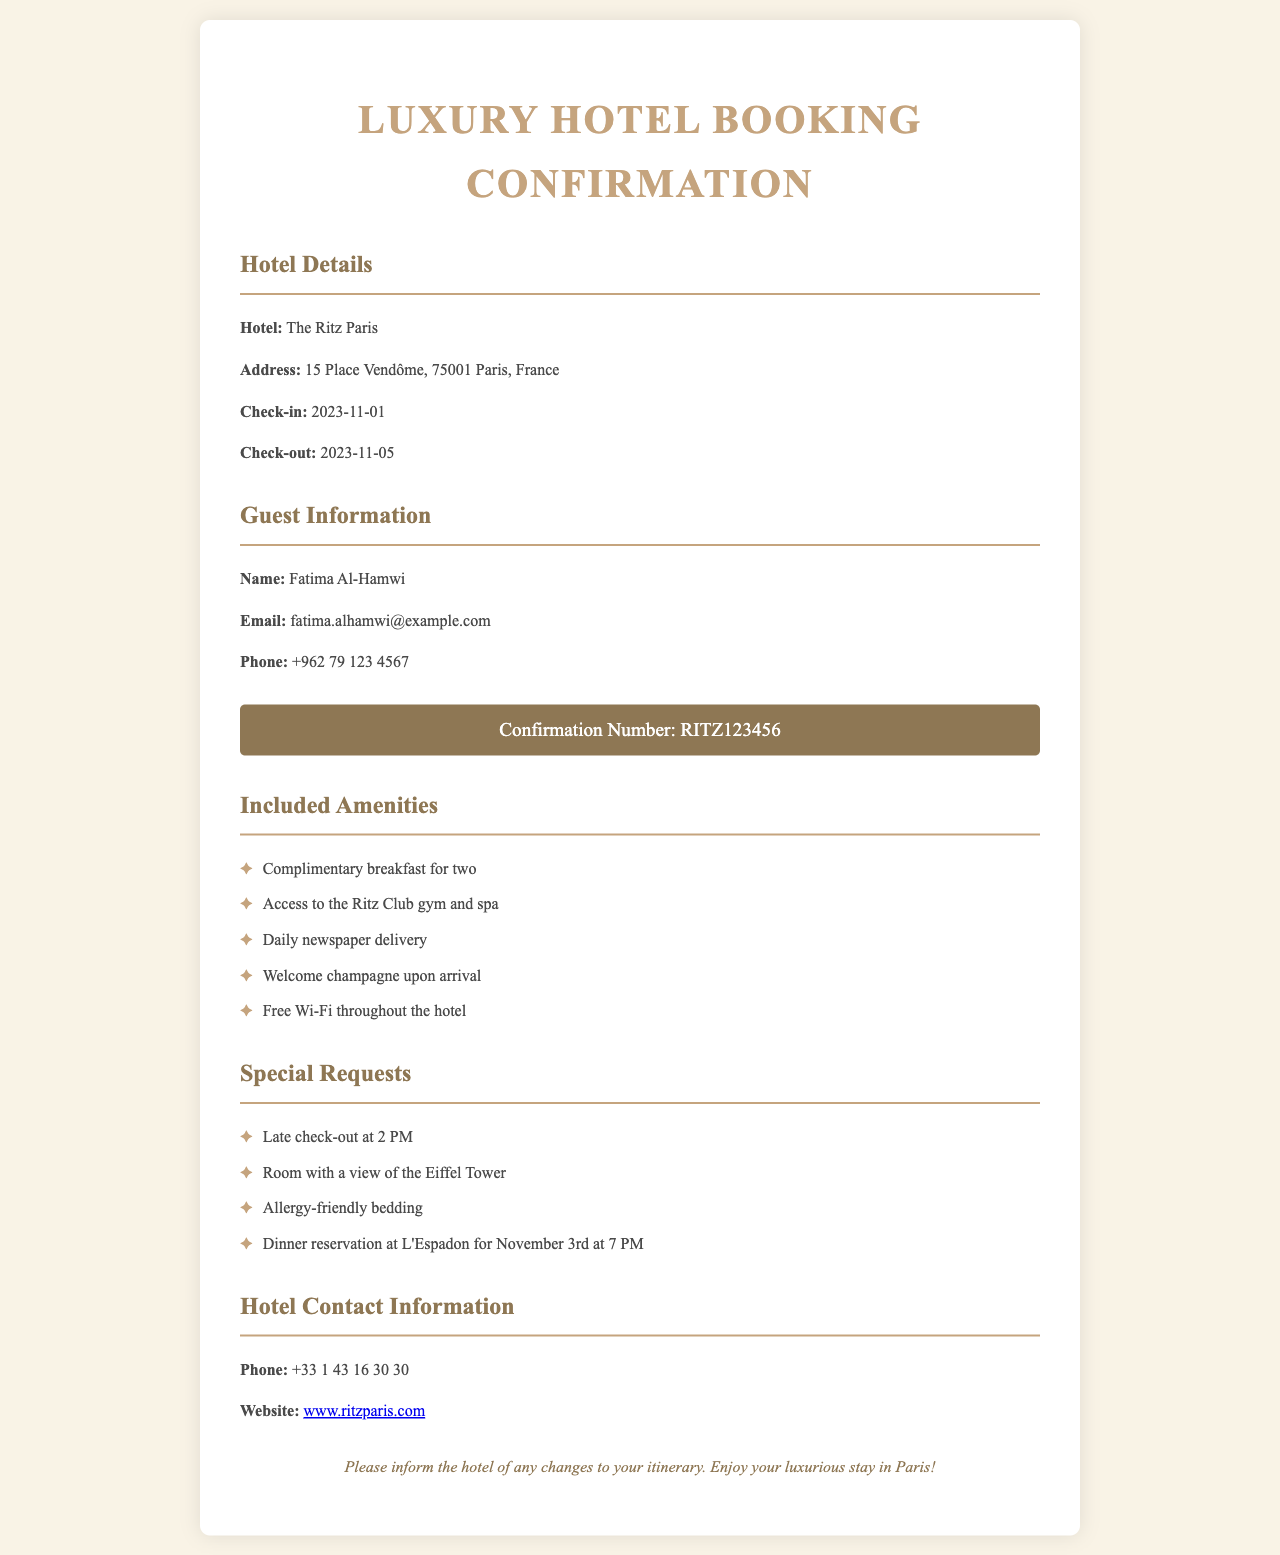What is the hotel name? The hotel name is mentioned in the hotel details section of the document.
Answer: The Ritz Paris What are the check-in and check-out dates? The check-in and check-out dates are specified in the hotel details section.
Answer: 2023-11-01 and 2023-11-05 What amenities are included? The document lists several amenities included with the stay.
Answer: Complimentary breakfast for two, Access to the Ritz Club gym and spa, Daily newspaper delivery, Welcome champagne upon arrival, Free Wi-Fi throughout the hotel What special requests did Fatima make? The special requests are listed under the special requests section of the document.
Answer: Late check-out at 2 PM, Room with a view of the Eiffel Tower, Allergy-friendly bedding, Dinner reservation at L'Espadon for November 3rd at 7 PM What is the confirmation number? The confirmation number is provided in a highlighted section dedicated to the reservation details.
Answer: RITZ123456 What is the hotel's phone number? The hotel's phone number is indicated in the contact information section of the document.
Answer: +33 1 43 16 30 30 What email address did Fatima provide? The email address for the guest is found in the guest information section.
Answer: fatima.alhamwi@example.com How many nights will Fatima stay at the hotel? The number of nights can be calculated from the check-in and check-out dates provided.
Answer: 4 nights What type of room view did she request? The requested room view is mentioned in the special requests section of the document.
Answer: Eiffel Tower 